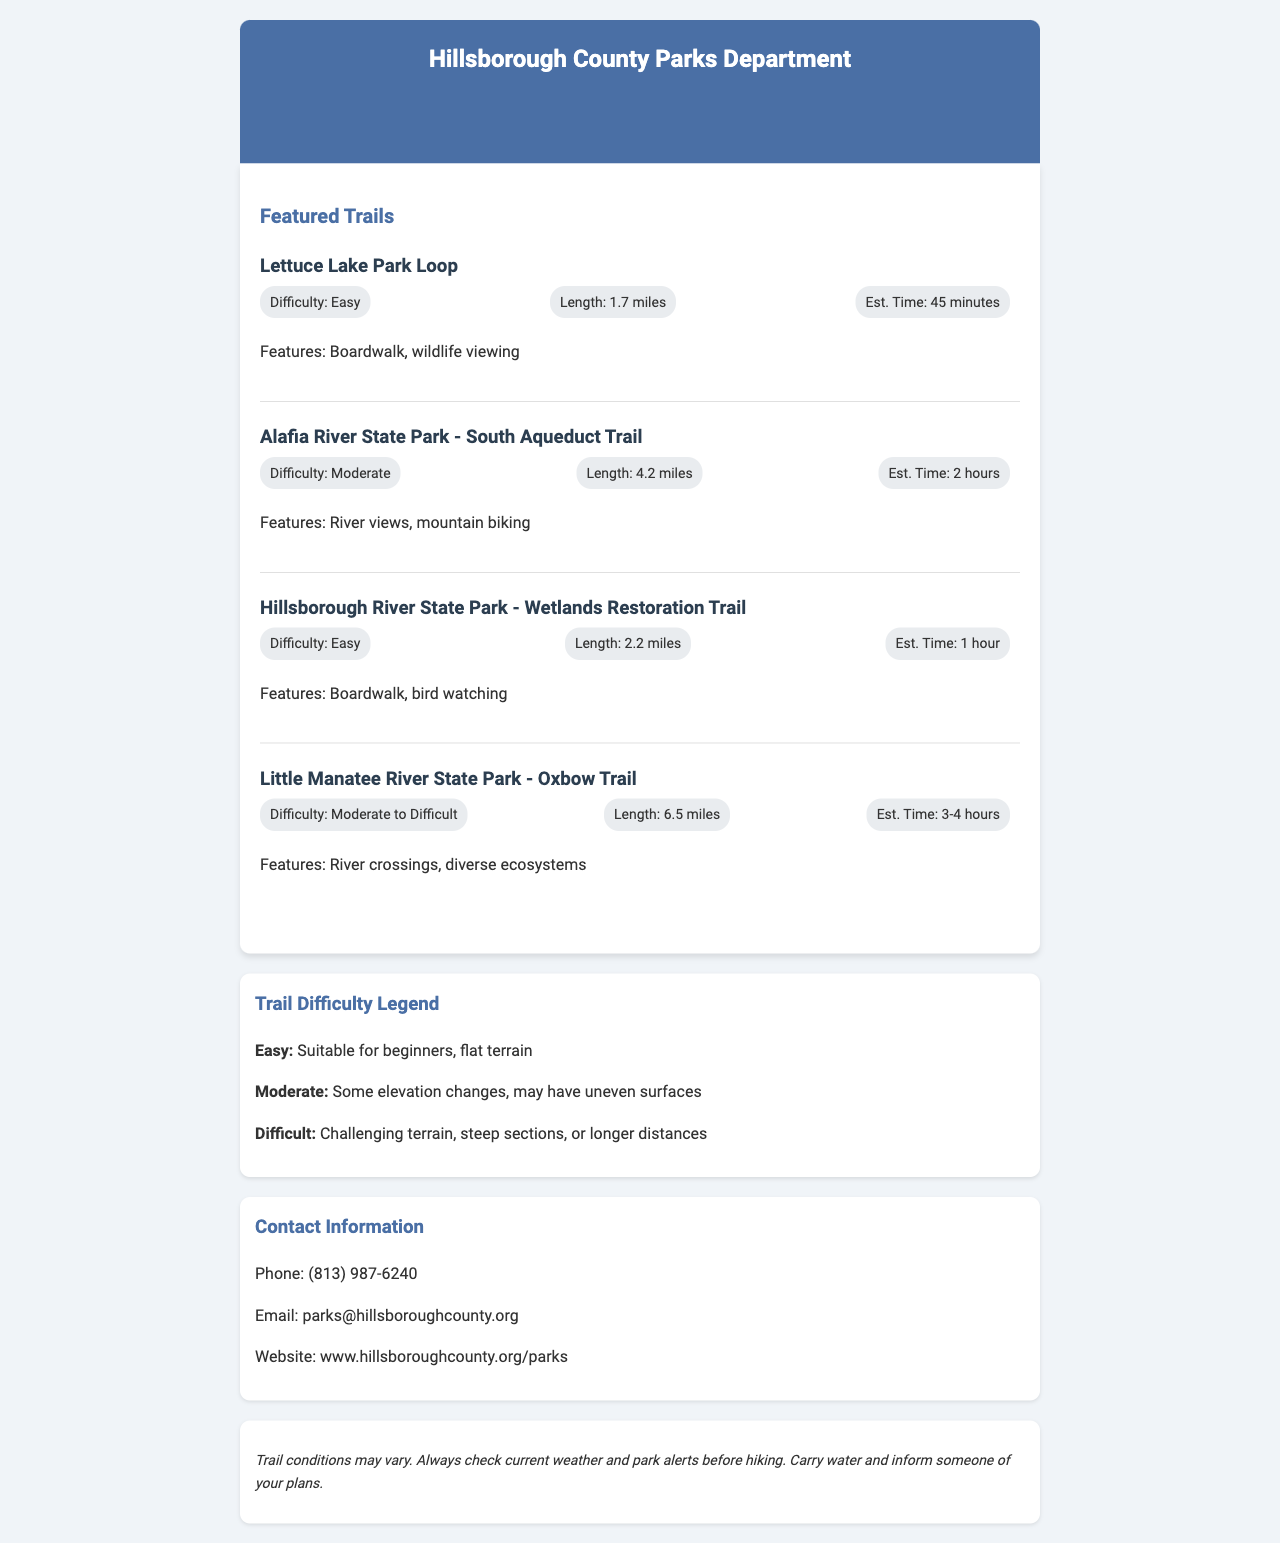What is the title of the fax? The title of the fax is found in the header section, which announces the document as an official hiking trail map and guide.
Answer: Official Hiking Trail Map and Guide How long is the Lettuce Lake Park Loop? The length of the Lettuce Lake Park Loop is specified under its details.
Answer: 1.7 miles What is the difficulty rating for the Little Manatee River State Park - Oxbow Trail? The difficulty rating is listed in the trail's detailed section in the document.
Answer: Moderate to Difficult What feature is highlighted for the Alafia River State Park - South Aqueduct Trail? The features of the trail are mentioned in a description right after its details.
Answer: River views, mountain biking How much time should you estimate for hiking the Hillsborough River State Park - Wetlands Restoration Trail? The estimated completion time is stated in the trail's information.
Answer: 1 hour 